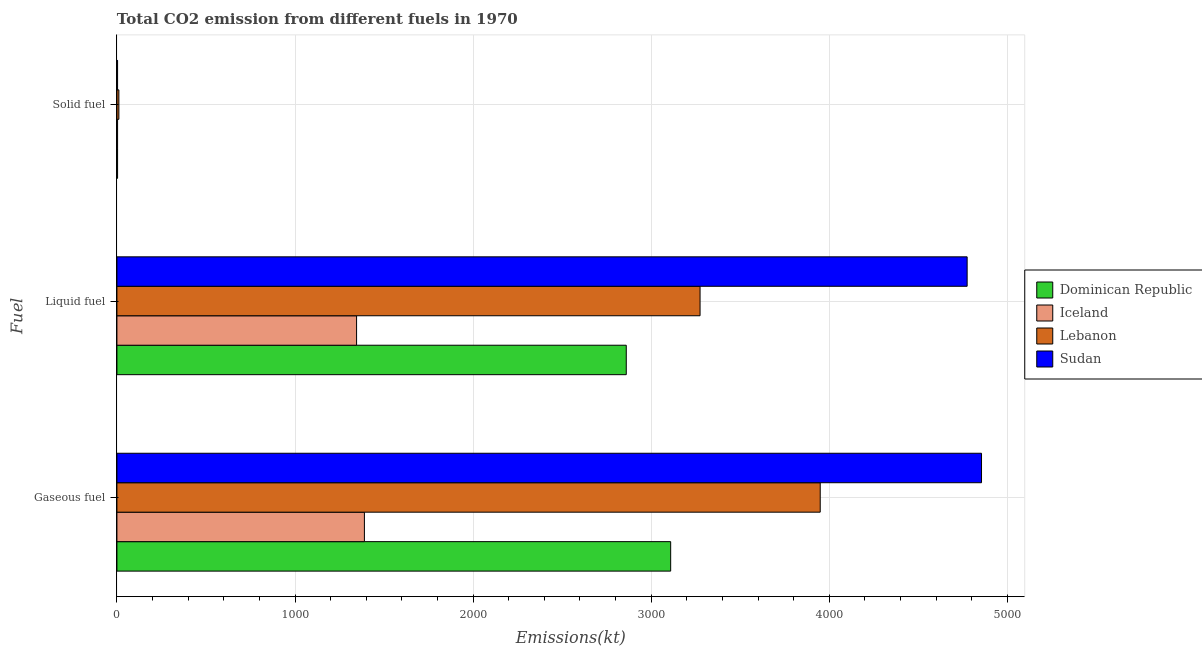How many different coloured bars are there?
Provide a succinct answer. 4. Are the number of bars on each tick of the Y-axis equal?
Provide a succinct answer. Yes. How many bars are there on the 2nd tick from the bottom?
Keep it short and to the point. 4. What is the label of the 3rd group of bars from the top?
Offer a very short reply. Gaseous fuel. What is the amount of co2 emissions from liquid fuel in Lebanon?
Give a very brief answer. 3274.63. Across all countries, what is the maximum amount of co2 emissions from gaseous fuel?
Offer a terse response. 4855.11. Across all countries, what is the minimum amount of co2 emissions from solid fuel?
Your answer should be very brief. 3.67. In which country was the amount of co2 emissions from liquid fuel maximum?
Offer a terse response. Sudan. In which country was the amount of co2 emissions from liquid fuel minimum?
Make the answer very short. Iceland. What is the total amount of co2 emissions from solid fuel in the graph?
Give a very brief answer. 22. What is the difference between the amount of co2 emissions from liquid fuel in Lebanon and that in Sudan?
Your answer should be very brief. -1499.8. What is the difference between the amount of co2 emissions from solid fuel in Lebanon and the amount of co2 emissions from gaseous fuel in Dominican Republic?
Your response must be concise. -3098.61. What is the average amount of co2 emissions from solid fuel per country?
Make the answer very short. 5.5. What is the difference between the amount of co2 emissions from liquid fuel and amount of co2 emissions from solid fuel in Sudan?
Offer a terse response. 4770.77. In how many countries, is the amount of co2 emissions from gaseous fuel greater than 2600 kt?
Provide a short and direct response. 3. What is the ratio of the amount of co2 emissions from gaseous fuel in Lebanon to that in Iceland?
Give a very brief answer. 2.84. Is the amount of co2 emissions from gaseous fuel in Sudan less than that in Iceland?
Give a very brief answer. No. Is the difference between the amount of co2 emissions from gaseous fuel in Lebanon and Sudan greater than the difference between the amount of co2 emissions from solid fuel in Lebanon and Sudan?
Offer a very short reply. No. What is the difference between the highest and the second highest amount of co2 emissions from gaseous fuel?
Provide a succinct answer. 905.75. What is the difference between the highest and the lowest amount of co2 emissions from liquid fuel?
Ensure brevity in your answer.  3428.65. What does the 4th bar from the top in Gaseous fuel represents?
Give a very brief answer. Dominican Republic. What does the 3rd bar from the bottom in Gaseous fuel represents?
Offer a very short reply. Lebanon. How many bars are there?
Your answer should be compact. 12. Are all the bars in the graph horizontal?
Your answer should be compact. Yes. How many countries are there in the graph?
Give a very brief answer. 4. What is the difference between two consecutive major ticks on the X-axis?
Offer a terse response. 1000. Are the values on the major ticks of X-axis written in scientific E-notation?
Your response must be concise. No. Where does the legend appear in the graph?
Provide a short and direct response. Center right. How many legend labels are there?
Make the answer very short. 4. How are the legend labels stacked?
Provide a short and direct response. Vertical. What is the title of the graph?
Keep it short and to the point. Total CO2 emission from different fuels in 1970. What is the label or title of the X-axis?
Offer a terse response. Emissions(kt). What is the label or title of the Y-axis?
Give a very brief answer. Fuel. What is the Emissions(kt) of Dominican Republic in Gaseous fuel?
Your answer should be very brief. 3109.62. What is the Emissions(kt) in Iceland in Gaseous fuel?
Offer a very short reply. 1389.79. What is the Emissions(kt) in Lebanon in Gaseous fuel?
Provide a succinct answer. 3949.36. What is the Emissions(kt) in Sudan in Gaseous fuel?
Offer a very short reply. 4855.11. What is the Emissions(kt) of Dominican Republic in Liquid fuel?
Your response must be concise. 2860.26. What is the Emissions(kt) of Iceland in Liquid fuel?
Keep it short and to the point. 1345.79. What is the Emissions(kt) of Lebanon in Liquid fuel?
Give a very brief answer. 3274.63. What is the Emissions(kt) in Sudan in Liquid fuel?
Make the answer very short. 4774.43. What is the Emissions(kt) in Dominican Republic in Solid fuel?
Offer a terse response. 3.67. What is the Emissions(kt) in Iceland in Solid fuel?
Offer a very short reply. 3.67. What is the Emissions(kt) of Lebanon in Solid fuel?
Offer a very short reply. 11. What is the Emissions(kt) of Sudan in Solid fuel?
Offer a terse response. 3.67. Across all Fuel, what is the maximum Emissions(kt) of Dominican Republic?
Make the answer very short. 3109.62. Across all Fuel, what is the maximum Emissions(kt) in Iceland?
Your answer should be compact. 1389.79. Across all Fuel, what is the maximum Emissions(kt) of Lebanon?
Provide a succinct answer. 3949.36. Across all Fuel, what is the maximum Emissions(kt) in Sudan?
Make the answer very short. 4855.11. Across all Fuel, what is the minimum Emissions(kt) in Dominican Republic?
Give a very brief answer. 3.67. Across all Fuel, what is the minimum Emissions(kt) of Iceland?
Your response must be concise. 3.67. Across all Fuel, what is the minimum Emissions(kt) in Lebanon?
Your response must be concise. 11. Across all Fuel, what is the minimum Emissions(kt) in Sudan?
Ensure brevity in your answer.  3.67. What is the total Emissions(kt) in Dominican Republic in the graph?
Provide a short and direct response. 5973.54. What is the total Emissions(kt) in Iceland in the graph?
Offer a very short reply. 2739.25. What is the total Emissions(kt) in Lebanon in the graph?
Offer a terse response. 7234.99. What is the total Emissions(kt) of Sudan in the graph?
Make the answer very short. 9633.21. What is the difference between the Emissions(kt) in Dominican Republic in Gaseous fuel and that in Liquid fuel?
Your answer should be compact. 249.36. What is the difference between the Emissions(kt) of Iceland in Gaseous fuel and that in Liquid fuel?
Make the answer very short. 44. What is the difference between the Emissions(kt) of Lebanon in Gaseous fuel and that in Liquid fuel?
Your response must be concise. 674.73. What is the difference between the Emissions(kt) of Sudan in Gaseous fuel and that in Liquid fuel?
Your answer should be very brief. 80.67. What is the difference between the Emissions(kt) of Dominican Republic in Gaseous fuel and that in Solid fuel?
Make the answer very short. 3105.95. What is the difference between the Emissions(kt) in Iceland in Gaseous fuel and that in Solid fuel?
Provide a succinct answer. 1386.13. What is the difference between the Emissions(kt) of Lebanon in Gaseous fuel and that in Solid fuel?
Keep it short and to the point. 3938.36. What is the difference between the Emissions(kt) in Sudan in Gaseous fuel and that in Solid fuel?
Provide a succinct answer. 4851.44. What is the difference between the Emissions(kt) of Dominican Republic in Liquid fuel and that in Solid fuel?
Provide a short and direct response. 2856.59. What is the difference between the Emissions(kt) of Iceland in Liquid fuel and that in Solid fuel?
Your answer should be very brief. 1342.12. What is the difference between the Emissions(kt) in Lebanon in Liquid fuel and that in Solid fuel?
Give a very brief answer. 3263.63. What is the difference between the Emissions(kt) in Sudan in Liquid fuel and that in Solid fuel?
Keep it short and to the point. 4770.77. What is the difference between the Emissions(kt) in Dominican Republic in Gaseous fuel and the Emissions(kt) in Iceland in Liquid fuel?
Provide a succinct answer. 1763.83. What is the difference between the Emissions(kt) of Dominican Republic in Gaseous fuel and the Emissions(kt) of Lebanon in Liquid fuel?
Provide a succinct answer. -165.01. What is the difference between the Emissions(kt) in Dominican Republic in Gaseous fuel and the Emissions(kt) in Sudan in Liquid fuel?
Offer a terse response. -1664.82. What is the difference between the Emissions(kt) in Iceland in Gaseous fuel and the Emissions(kt) in Lebanon in Liquid fuel?
Offer a very short reply. -1884.84. What is the difference between the Emissions(kt) of Iceland in Gaseous fuel and the Emissions(kt) of Sudan in Liquid fuel?
Provide a succinct answer. -3384.64. What is the difference between the Emissions(kt) of Lebanon in Gaseous fuel and the Emissions(kt) of Sudan in Liquid fuel?
Your answer should be very brief. -825.08. What is the difference between the Emissions(kt) of Dominican Republic in Gaseous fuel and the Emissions(kt) of Iceland in Solid fuel?
Offer a very short reply. 3105.95. What is the difference between the Emissions(kt) of Dominican Republic in Gaseous fuel and the Emissions(kt) of Lebanon in Solid fuel?
Ensure brevity in your answer.  3098.61. What is the difference between the Emissions(kt) in Dominican Republic in Gaseous fuel and the Emissions(kt) in Sudan in Solid fuel?
Your answer should be compact. 3105.95. What is the difference between the Emissions(kt) of Iceland in Gaseous fuel and the Emissions(kt) of Lebanon in Solid fuel?
Your answer should be compact. 1378.79. What is the difference between the Emissions(kt) of Iceland in Gaseous fuel and the Emissions(kt) of Sudan in Solid fuel?
Offer a terse response. 1386.13. What is the difference between the Emissions(kt) of Lebanon in Gaseous fuel and the Emissions(kt) of Sudan in Solid fuel?
Provide a succinct answer. 3945.69. What is the difference between the Emissions(kt) of Dominican Republic in Liquid fuel and the Emissions(kt) of Iceland in Solid fuel?
Ensure brevity in your answer.  2856.59. What is the difference between the Emissions(kt) in Dominican Republic in Liquid fuel and the Emissions(kt) in Lebanon in Solid fuel?
Your answer should be compact. 2849.26. What is the difference between the Emissions(kt) in Dominican Republic in Liquid fuel and the Emissions(kt) in Sudan in Solid fuel?
Your response must be concise. 2856.59. What is the difference between the Emissions(kt) in Iceland in Liquid fuel and the Emissions(kt) in Lebanon in Solid fuel?
Your answer should be very brief. 1334.79. What is the difference between the Emissions(kt) of Iceland in Liquid fuel and the Emissions(kt) of Sudan in Solid fuel?
Ensure brevity in your answer.  1342.12. What is the difference between the Emissions(kt) of Lebanon in Liquid fuel and the Emissions(kt) of Sudan in Solid fuel?
Your answer should be compact. 3270.96. What is the average Emissions(kt) of Dominican Republic per Fuel?
Ensure brevity in your answer.  1991.18. What is the average Emissions(kt) in Iceland per Fuel?
Make the answer very short. 913.08. What is the average Emissions(kt) of Lebanon per Fuel?
Make the answer very short. 2411.66. What is the average Emissions(kt) of Sudan per Fuel?
Provide a short and direct response. 3211.07. What is the difference between the Emissions(kt) in Dominican Republic and Emissions(kt) in Iceland in Gaseous fuel?
Give a very brief answer. 1719.82. What is the difference between the Emissions(kt) of Dominican Republic and Emissions(kt) of Lebanon in Gaseous fuel?
Offer a terse response. -839.74. What is the difference between the Emissions(kt) of Dominican Republic and Emissions(kt) of Sudan in Gaseous fuel?
Provide a succinct answer. -1745.49. What is the difference between the Emissions(kt) of Iceland and Emissions(kt) of Lebanon in Gaseous fuel?
Provide a short and direct response. -2559.57. What is the difference between the Emissions(kt) of Iceland and Emissions(kt) of Sudan in Gaseous fuel?
Offer a very short reply. -3465.32. What is the difference between the Emissions(kt) of Lebanon and Emissions(kt) of Sudan in Gaseous fuel?
Provide a short and direct response. -905.75. What is the difference between the Emissions(kt) in Dominican Republic and Emissions(kt) in Iceland in Liquid fuel?
Provide a succinct answer. 1514.47. What is the difference between the Emissions(kt) of Dominican Republic and Emissions(kt) of Lebanon in Liquid fuel?
Your response must be concise. -414.37. What is the difference between the Emissions(kt) of Dominican Republic and Emissions(kt) of Sudan in Liquid fuel?
Offer a terse response. -1914.17. What is the difference between the Emissions(kt) of Iceland and Emissions(kt) of Lebanon in Liquid fuel?
Keep it short and to the point. -1928.84. What is the difference between the Emissions(kt) of Iceland and Emissions(kt) of Sudan in Liquid fuel?
Give a very brief answer. -3428.64. What is the difference between the Emissions(kt) in Lebanon and Emissions(kt) in Sudan in Liquid fuel?
Make the answer very short. -1499.8. What is the difference between the Emissions(kt) of Dominican Republic and Emissions(kt) of Iceland in Solid fuel?
Your answer should be very brief. 0. What is the difference between the Emissions(kt) in Dominican Republic and Emissions(kt) in Lebanon in Solid fuel?
Offer a very short reply. -7.33. What is the difference between the Emissions(kt) of Dominican Republic and Emissions(kt) of Sudan in Solid fuel?
Your answer should be compact. 0. What is the difference between the Emissions(kt) in Iceland and Emissions(kt) in Lebanon in Solid fuel?
Give a very brief answer. -7.33. What is the difference between the Emissions(kt) of Iceland and Emissions(kt) of Sudan in Solid fuel?
Your answer should be very brief. 0. What is the difference between the Emissions(kt) in Lebanon and Emissions(kt) in Sudan in Solid fuel?
Give a very brief answer. 7.33. What is the ratio of the Emissions(kt) in Dominican Republic in Gaseous fuel to that in Liquid fuel?
Offer a very short reply. 1.09. What is the ratio of the Emissions(kt) in Iceland in Gaseous fuel to that in Liquid fuel?
Provide a succinct answer. 1.03. What is the ratio of the Emissions(kt) in Lebanon in Gaseous fuel to that in Liquid fuel?
Give a very brief answer. 1.21. What is the ratio of the Emissions(kt) in Sudan in Gaseous fuel to that in Liquid fuel?
Keep it short and to the point. 1.02. What is the ratio of the Emissions(kt) in Dominican Republic in Gaseous fuel to that in Solid fuel?
Your answer should be compact. 848. What is the ratio of the Emissions(kt) in Iceland in Gaseous fuel to that in Solid fuel?
Offer a very short reply. 379. What is the ratio of the Emissions(kt) in Lebanon in Gaseous fuel to that in Solid fuel?
Ensure brevity in your answer.  359. What is the ratio of the Emissions(kt) of Sudan in Gaseous fuel to that in Solid fuel?
Make the answer very short. 1324. What is the ratio of the Emissions(kt) in Dominican Republic in Liquid fuel to that in Solid fuel?
Offer a terse response. 780. What is the ratio of the Emissions(kt) in Iceland in Liquid fuel to that in Solid fuel?
Offer a very short reply. 367. What is the ratio of the Emissions(kt) in Lebanon in Liquid fuel to that in Solid fuel?
Offer a terse response. 297.67. What is the ratio of the Emissions(kt) of Sudan in Liquid fuel to that in Solid fuel?
Your answer should be very brief. 1302. What is the difference between the highest and the second highest Emissions(kt) in Dominican Republic?
Provide a short and direct response. 249.36. What is the difference between the highest and the second highest Emissions(kt) in Iceland?
Provide a succinct answer. 44. What is the difference between the highest and the second highest Emissions(kt) in Lebanon?
Provide a short and direct response. 674.73. What is the difference between the highest and the second highest Emissions(kt) of Sudan?
Ensure brevity in your answer.  80.67. What is the difference between the highest and the lowest Emissions(kt) in Dominican Republic?
Keep it short and to the point. 3105.95. What is the difference between the highest and the lowest Emissions(kt) of Iceland?
Your answer should be compact. 1386.13. What is the difference between the highest and the lowest Emissions(kt) in Lebanon?
Provide a succinct answer. 3938.36. What is the difference between the highest and the lowest Emissions(kt) of Sudan?
Make the answer very short. 4851.44. 